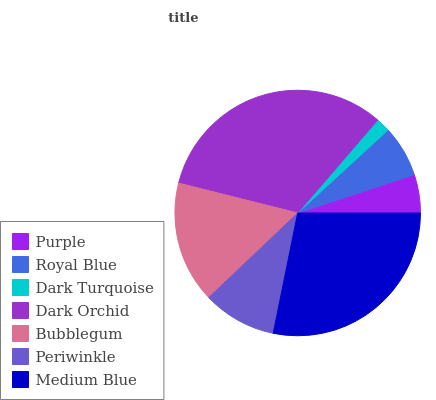Is Dark Turquoise the minimum?
Answer yes or no. Yes. Is Dark Orchid the maximum?
Answer yes or no. Yes. Is Royal Blue the minimum?
Answer yes or no. No. Is Royal Blue the maximum?
Answer yes or no. No. Is Royal Blue greater than Purple?
Answer yes or no. Yes. Is Purple less than Royal Blue?
Answer yes or no. Yes. Is Purple greater than Royal Blue?
Answer yes or no. No. Is Royal Blue less than Purple?
Answer yes or no. No. Is Periwinkle the high median?
Answer yes or no. Yes. Is Periwinkle the low median?
Answer yes or no. Yes. Is Royal Blue the high median?
Answer yes or no. No. Is Royal Blue the low median?
Answer yes or no. No. 